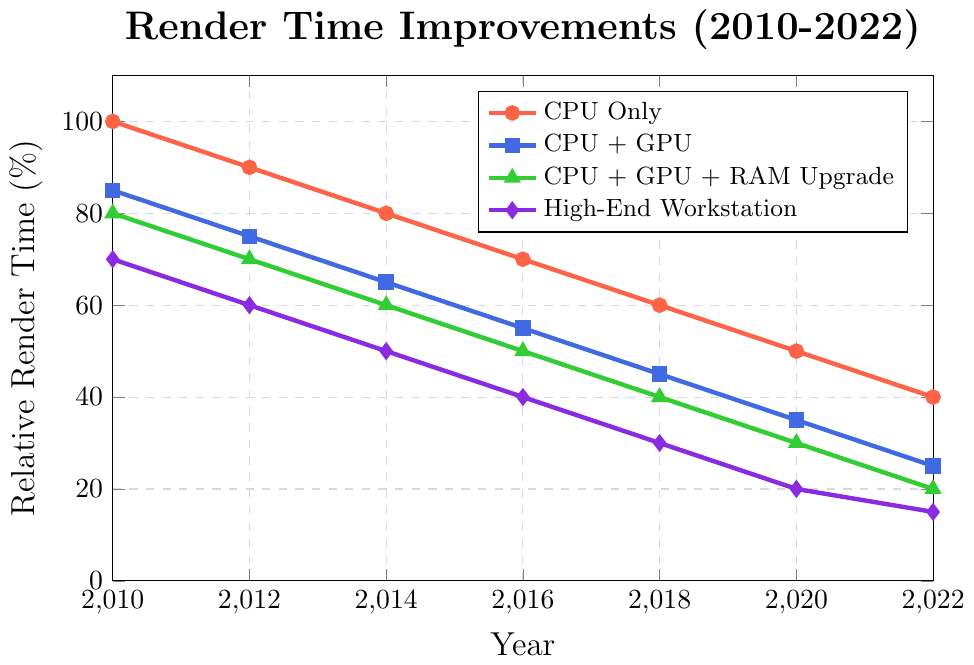What hardware configuration had the least render time in 2022? The figure shows that the "High-End Workstation" has the minimum relative render time in 2022 by having the lowest position on the y-axis for that year.
Answer: High-End Workstation How much did the relative render time for CPU Only improve from 2010 to 2022? To determine the total improvement, subtract the render time in 2022 from that in 2010. This is 100% - 40% = 60%.
Answer: 60% Which year saw the largest decrease in render time for CPU + GPU + RAM Upgrade? The largest decrease in render time for CPU + GPU + RAM Upgrade can be observed by finding the steepest negative slope between consecutive years. The steepest drop is between 2010 (80%) and 2012 (70%), resulting in a 10% decrease.
Answer: 2010-2012 What is the average render time for High-End Workstation across all years? Sum up all the values for High-End Workstation (70 + 60 + 50 + 40 + 30 + 20 + 15 = 285) and divide by the number of data points (7). 285 / 7 = 40.71 (approx)
Answer: 40.71 In which year did CPU + GPU reach the same render time that CPU Only had in 2014? First, find the render time for CPU Only in 2014, which is 80%. Then, look for the year in the CPU + GPU series that matches this value. CPU + GPU reaches 80% in 2010.
Answer: 2010 Compare the improvement in relative render time of CPU Only and CPU + GPU from 2010 to 2016. Which improved more? CPU Only improved from 100% to 70%, which is a 30% improvement. CPU + GPU improved from 85% to 55%, which is also a 30% improvement. Both configurations had equal improvements.
Answer: Both equal What is the difference in relative render time between CPU Only and High-End Workstation in 2020? Subtract the relative render time of High-End Workstation (20%) from that of CPU Only (50%) for the year 2020. 50% - 20% = 30%.
Answer: 30% For CPU + GPU + RAM Upgrade, how much was the render time reduced between 2014 and 2018? Subtract the relative render time in 2018 (40%) from that in 2014 (60%) for CPU + GPU + RAM Upgrade. 60% - 40% = 20%.
Answer: 20% What trend do you observe in the High-End Workstation render times from 2010 to 2022, and what does it suggest? The relative render times for High-End Workstation show a continuous decreasing trend from 70% in 2010 to 15% in 2022, suggesting consistent improvements in render performance over time.
Answer: Consistent improvement 